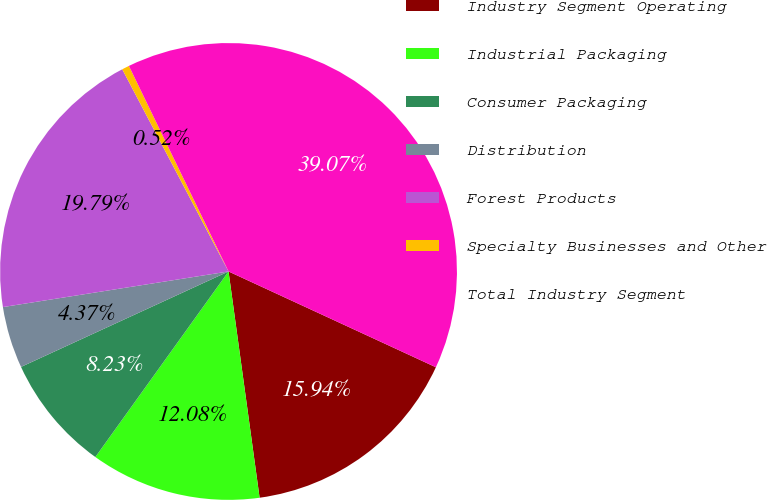Convert chart. <chart><loc_0><loc_0><loc_500><loc_500><pie_chart><fcel>Industry Segment Operating<fcel>Industrial Packaging<fcel>Consumer Packaging<fcel>Distribution<fcel>Forest Products<fcel>Specialty Businesses and Other<fcel>Total Industry Segment<nl><fcel>15.94%<fcel>12.08%<fcel>8.23%<fcel>4.37%<fcel>19.79%<fcel>0.52%<fcel>39.07%<nl></chart> 